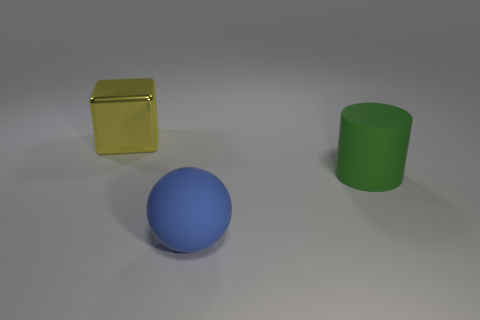How might the textures of these objects differ from one another? Based on the image, the block has a reflective, possibly metallic or glossy texture, while the cylinder seems to have a matte finish, potentially indicative of a plastic material. The sphere might have a smooth surface with a satin-like texture, as evidenced by its subtle light reflection and the way it scatters light. 